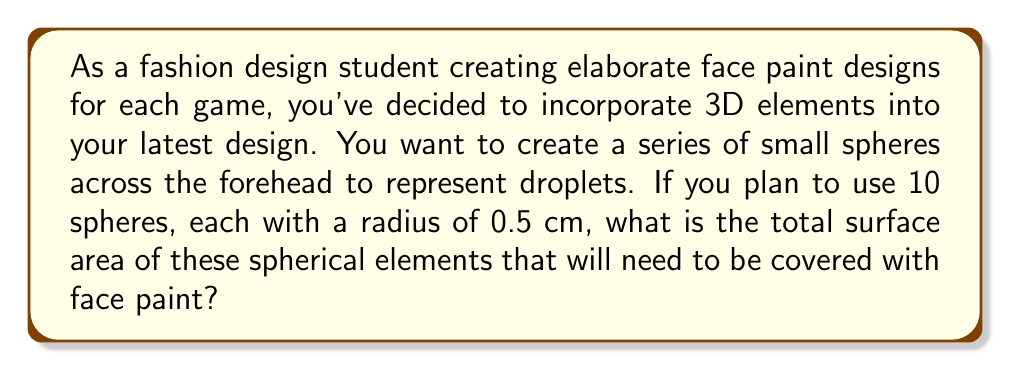Can you answer this question? To solve this problem, we need to follow these steps:

1. Recall the formula for the surface area of a sphere:
   $$A = 4\pi r^2$$
   where $A$ is the surface area and $r$ is the radius of the sphere.

2. Calculate the surface area of one sphere:
   $$A = 4\pi (0.5\text{ cm})^2 = 4\pi (0.25\text{ cm}^2) = \pi\text{ cm}^2$$

3. Since we have 10 identical spheres, multiply the surface area of one sphere by 10:
   $$\text{Total Surface Area} = 10 \times \pi\text{ cm}^2 = 10\pi\text{ cm}^2$$

4. To get the final numerical value, we can use $\pi \approx 3.14159$:
   $$10\pi\text{ cm}^2 \approx 10 \times 3.14159\text{ cm}^2 = 31.4159\text{ cm}^2$$

Therefore, the total surface area of the 10 spherical elements is $10\pi\text{ cm}^2$ or approximately $31.4159\text{ cm}^2$.
Answer: $10\pi\text{ cm}^2$ or approximately $31.4159\text{ cm}^2$ 